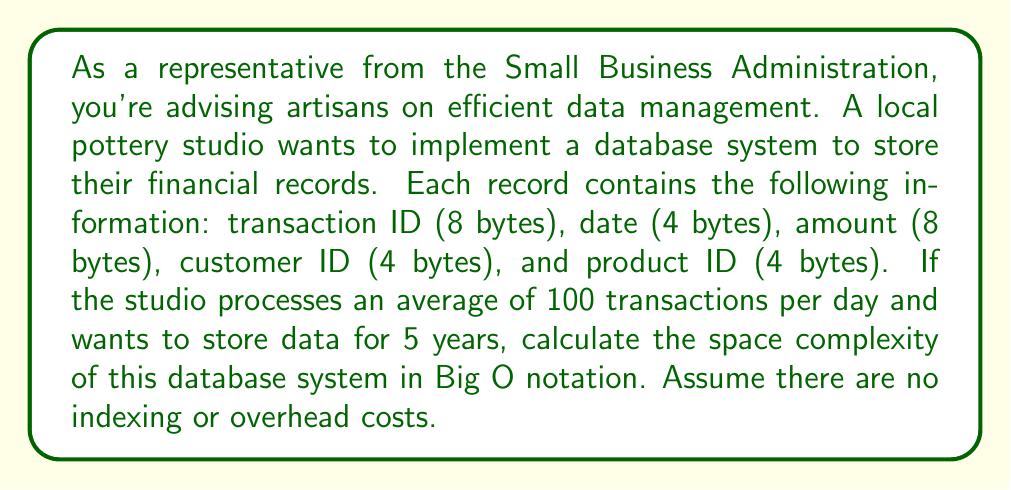Could you help me with this problem? To calculate the space complexity, we need to follow these steps:

1. Calculate the size of each record:
   $8 + 4 + 8 + 4 + 4 = 28$ bytes per record

2. Calculate the number of records over 5 years:
   $100$ transactions/day $\times 365$ days/year $\times 5$ years $= 182,500$ records

3. Calculate the total space required:
   $28$ bytes/record $\times 182,500$ records $= 5,110,000$ bytes

4. Express the space complexity in Big O notation:
   The space required grows linearly with the number of records. As the number of records increases, the space required increases proportionally. This is represented as $O(n)$, where $n$ is the number of records.

In this case, $n = 182,500$, but the exact number doesn't affect the Big O notation. Whether it's 100 records or 1,000,000 records, the space complexity remains $O(n)$ because the relationship between the number of records and the space required is linear.

It's important to note that this analysis assumes no additional overhead or indexing costs. In a real database system, there might be additional space requirements for indexing, which could potentially increase the space complexity to $O(n \log n)$ or higher, depending on the specific implementation.
Answer: The space complexity of the database system is $O(n)$, where $n$ is the number of records. 